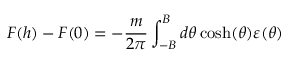<formula> <loc_0><loc_0><loc_500><loc_500>F ( h ) - F ( 0 ) = - \frac { m } { 2 \pi } \int _ { - B } ^ { B } d \theta \cosh ( \theta ) \varepsilon ( \theta )</formula> 